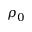Convert formula to latex. <formula><loc_0><loc_0><loc_500><loc_500>\rho _ { 0 }</formula> 